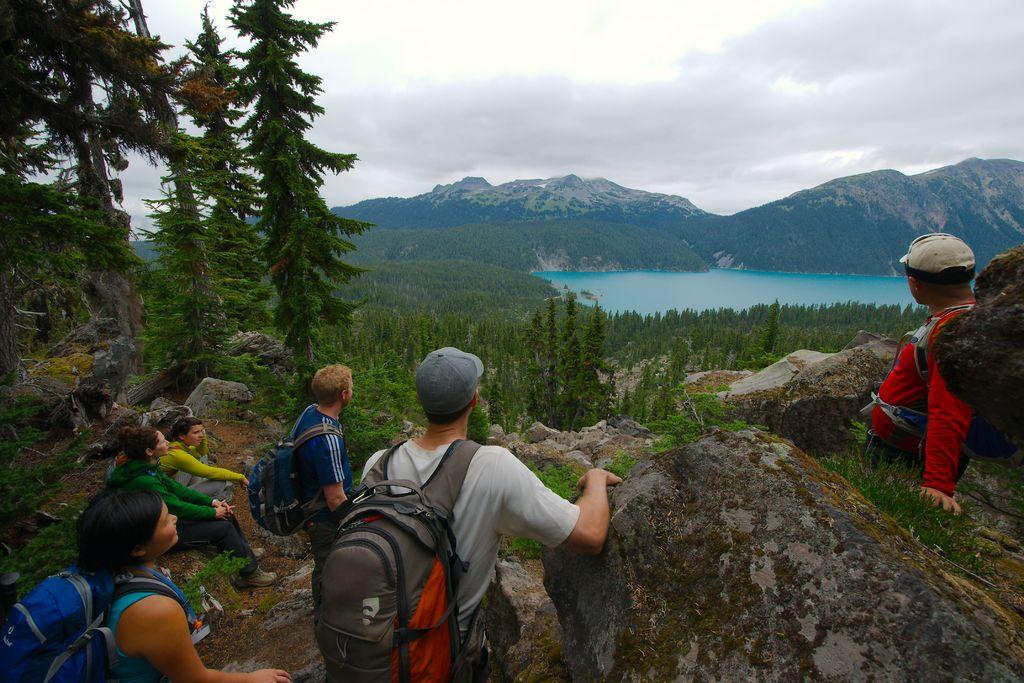What are the people in the image carrying on their backs? The people in the image are wearing backpacks. Where are the people located in the image? The people are on rocks in the image. What type of vegetation can be seen in the image? There are trees and plants in the image. What geographical features are visible in the background of the image? There are mountains and a lake in the image. What type of heart-shaped object can be seen floating in the lake in the image? There is no heart-shaped object floating in the lake in the image. How many chickens are present in the image? There are no chickens present in the image. 